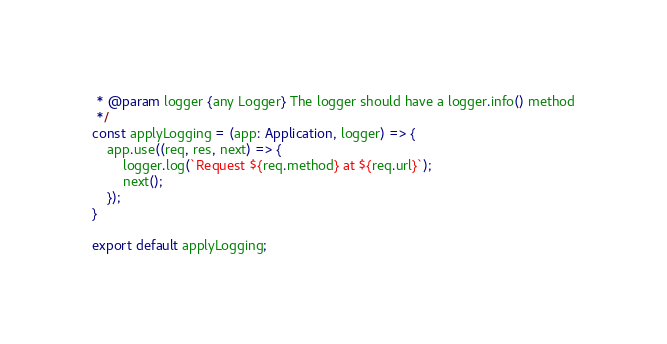<code> <loc_0><loc_0><loc_500><loc_500><_TypeScript_> * @param logger {any Logger} The logger should have a logger.info() method
 */
const applyLogging = (app: Application, logger) => {
    app.use((req, res, next) => {
        logger.log(`Request ${req.method} at ${req.url}`);
        next();
    });
}

export default applyLogging;</code> 